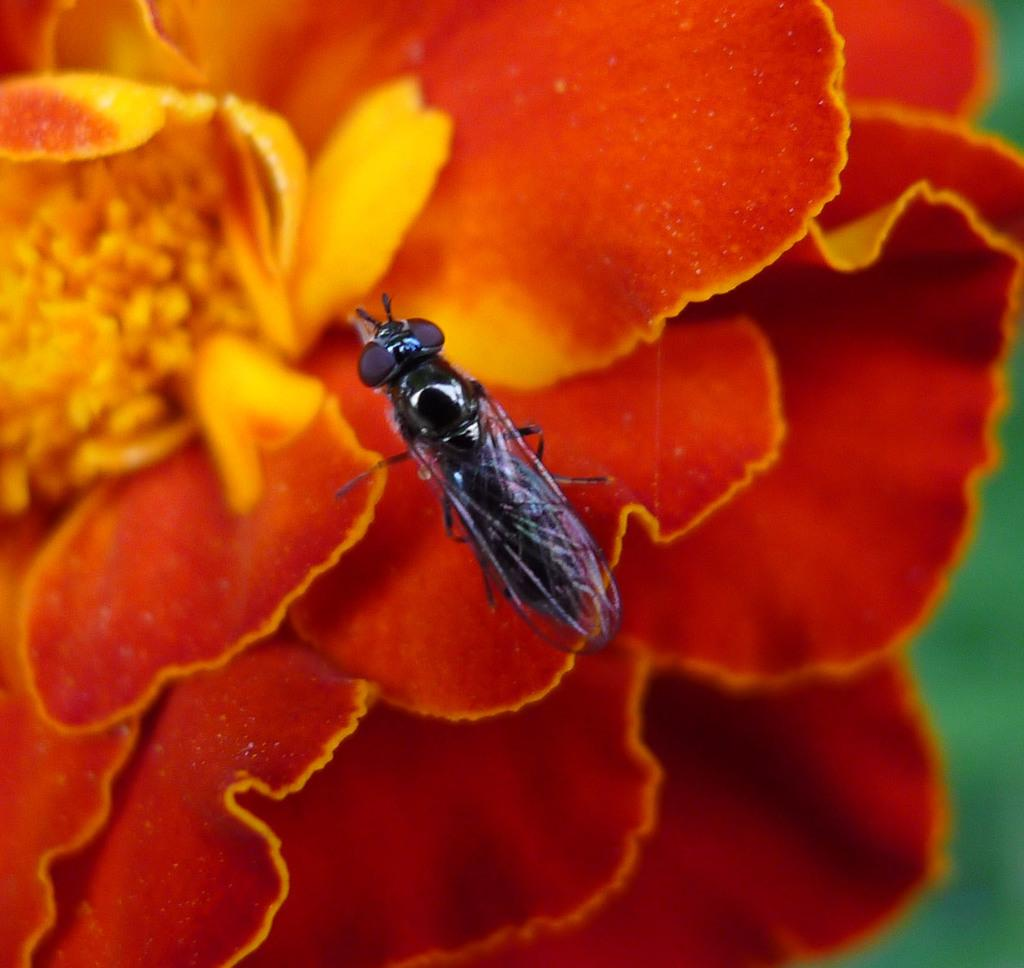What is present in the image along with the flower? There is an insect in the image. Where is the insect located on the flower? The insect is on the flower. Can you describe the background of the image? The background of the image is blurry. How many balls are visible in the image? There are no balls present in the image. What word is written on the flower in the image? There is no word written on the flower in the image. 